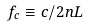<formula> <loc_0><loc_0><loc_500><loc_500>f _ { c } \equiv c / 2 n L</formula> 